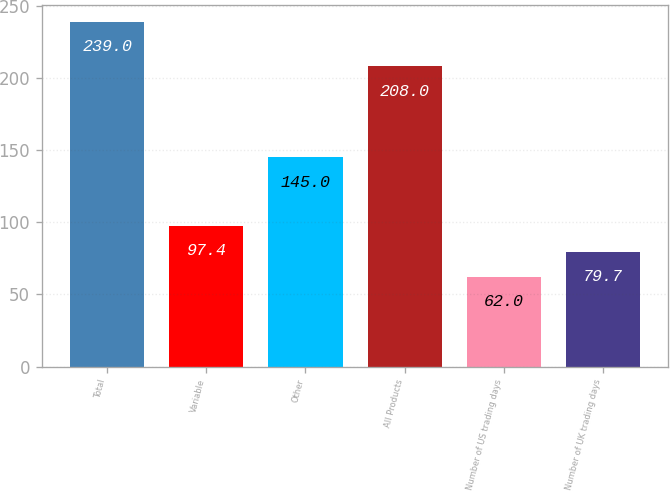Convert chart. <chart><loc_0><loc_0><loc_500><loc_500><bar_chart><fcel>Total<fcel>Variable<fcel>Other<fcel>All Products<fcel>Number of US trading days<fcel>Number of UK trading days<nl><fcel>239<fcel>97.4<fcel>145<fcel>208<fcel>62<fcel>79.7<nl></chart> 